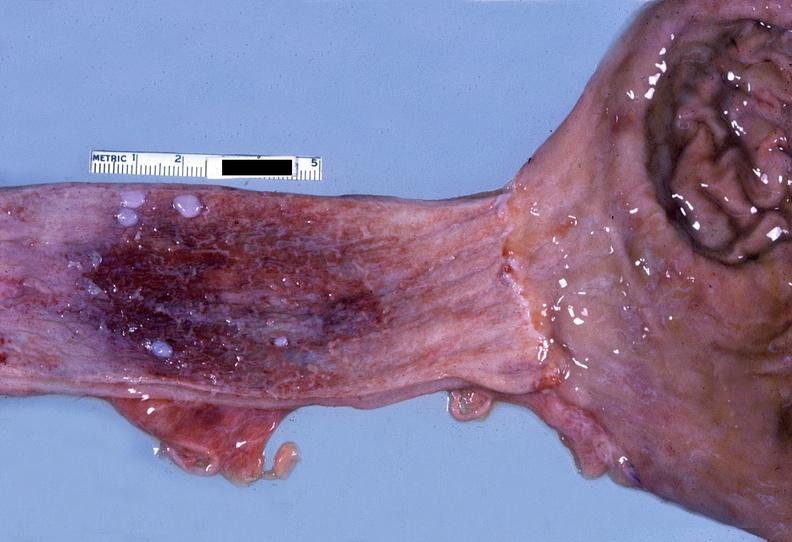s gastrointestinal present?
Answer the question using a single word or phrase. Yes 